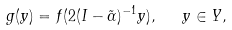<formula> <loc_0><loc_0><loc_500><loc_500>g ( y ) = f ( 2 ( I - \tilde { \alpha } ) ^ { - 1 } y ) , \ \ y \in Y ,</formula> 